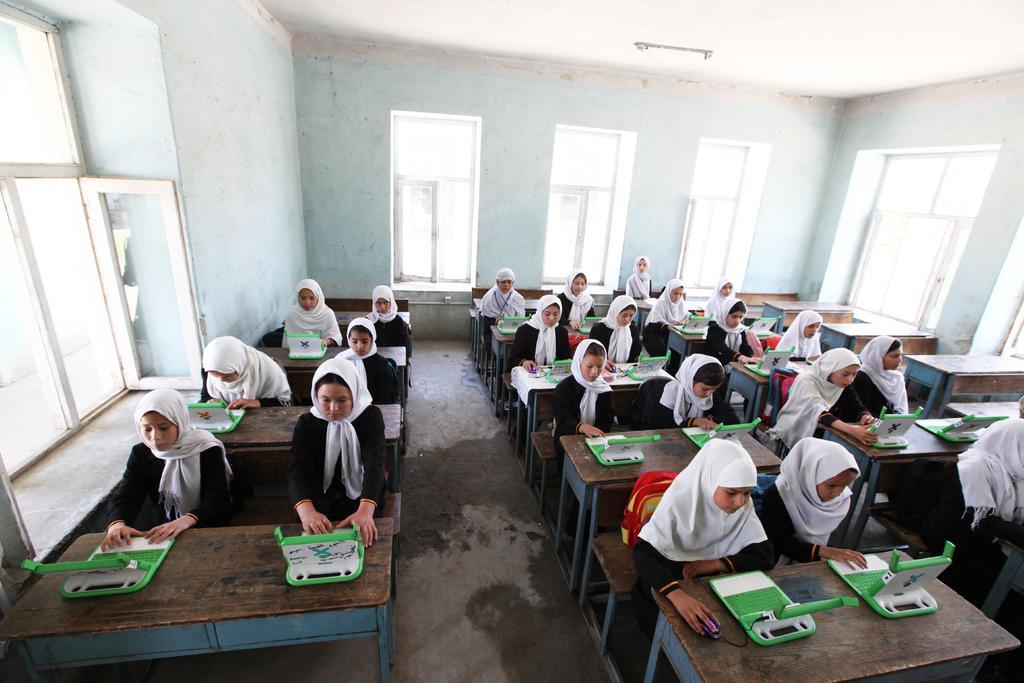How would you summarize this image in a sentence or two? Here we can see a group od students sitting on the benches and working in front of a devices. on the background we can see a white wall and windows. 